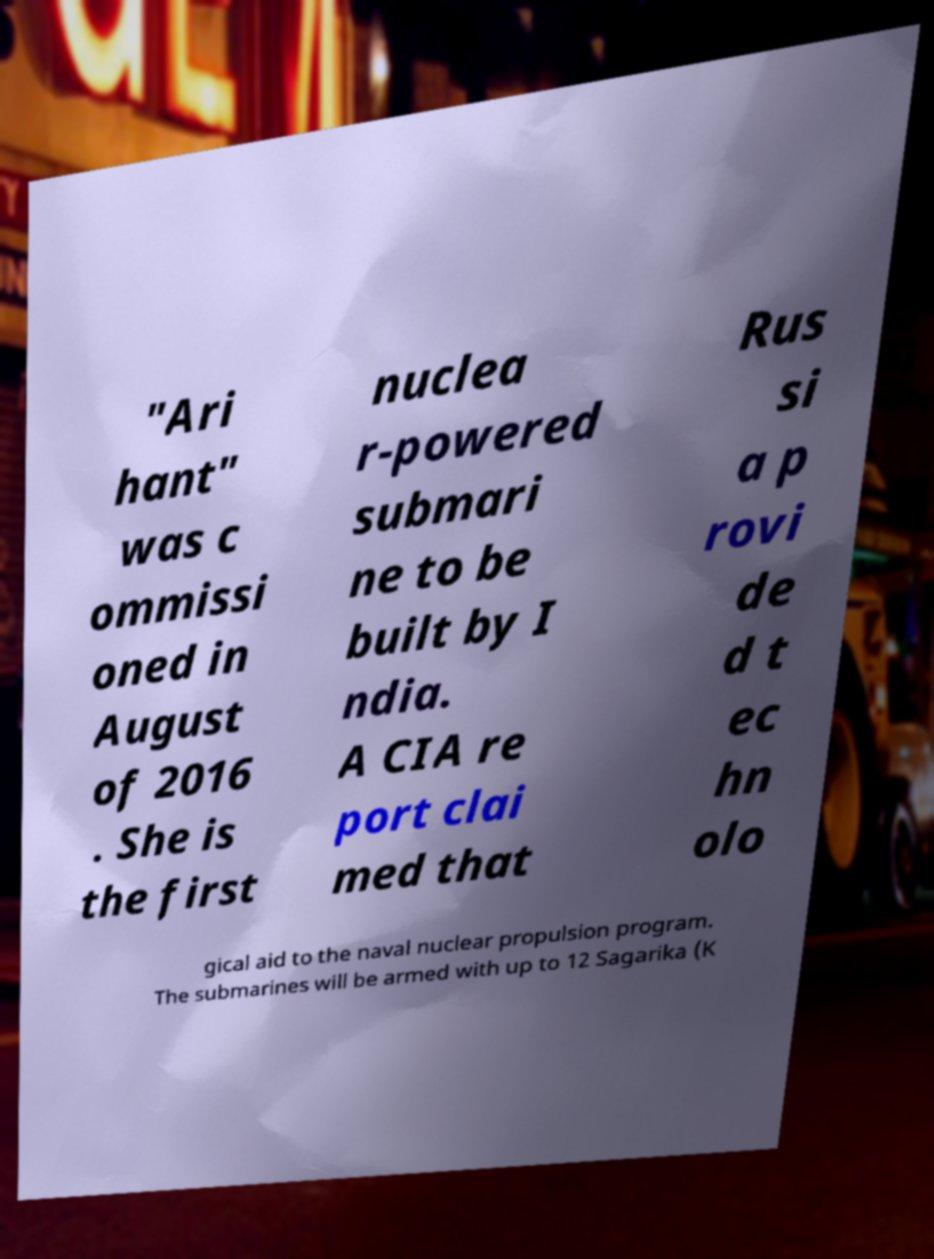Could you assist in decoding the text presented in this image and type it out clearly? "Ari hant" was c ommissi oned in August of 2016 . She is the first nuclea r-powered submari ne to be built by I ndia. A CIA re port clai med that Rus si a p rovi de d t ec hn olo gical aid to the naval nuclear propulsion program. The submarines will be armed with up to 12 Sagarika (K 